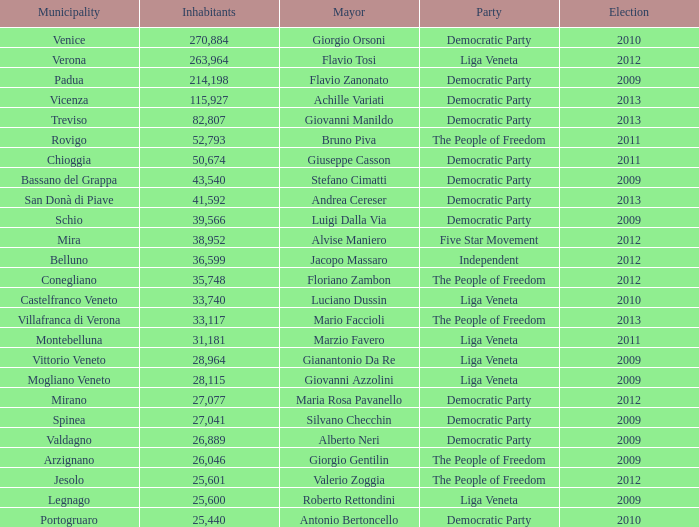Achille variati belonged to which party? Democratic Party. 